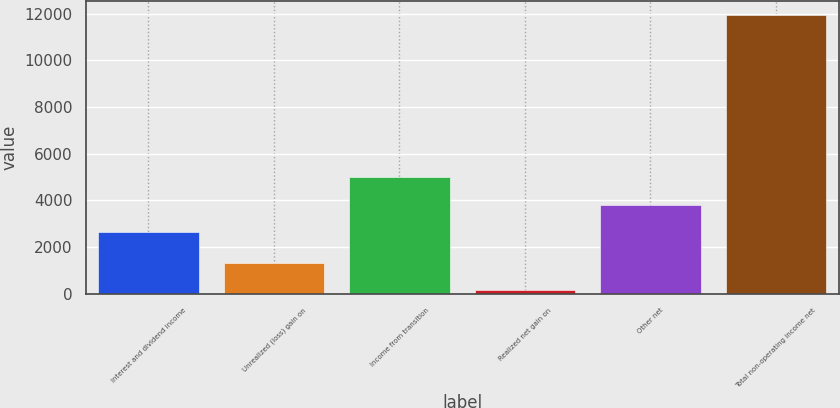<chart> <loc_0><loc_0><loc_500><loc_500><bar_chart><fcel>Interest and dividend income<fcel>Unrealized (loss) gain on<fcel>Income from transition<fcel>Realized net gain on<fcel>Other net<fcel>Total non-operating income net<nl><fcel>2638<fcel>1325<fcel>4998<fcel>145<fcel>3818<fcel>11945<nl></chart> 